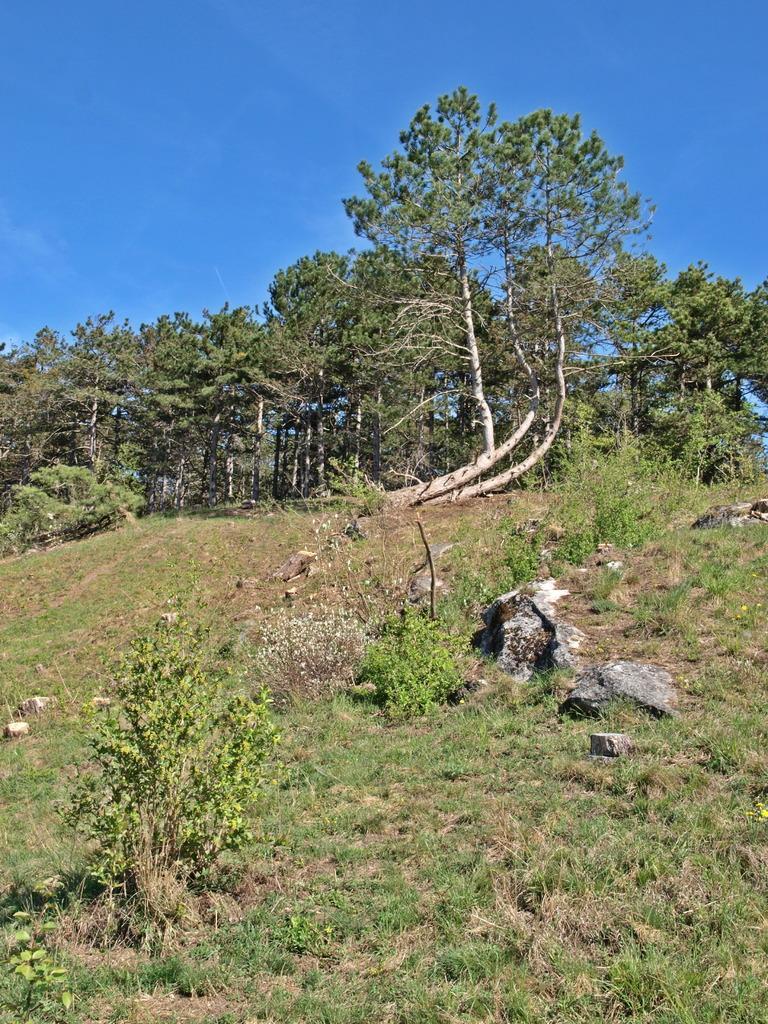Can you describe this image briefly? In this image there is a land on which there is grass and some small plants at the bottom. At the top there are trees. On the right side there are stones on the ground. At the top there is the sky. 